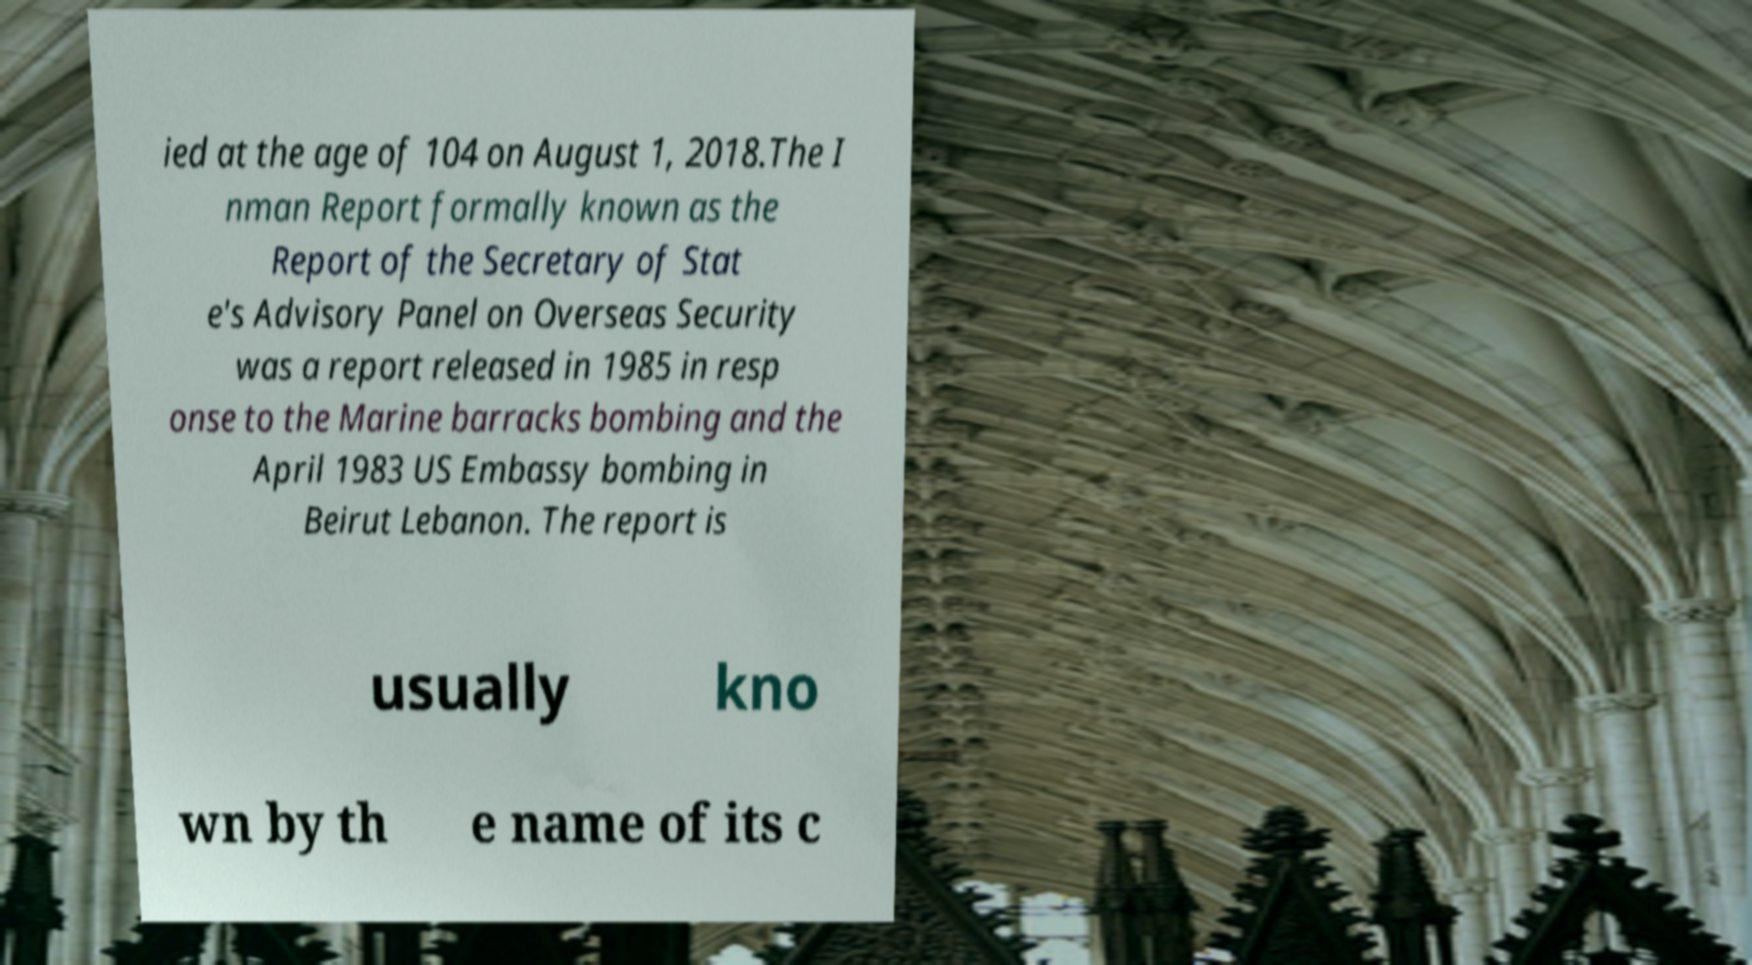I need the written content from this picture converted into text. Can you do that? ied at the age of 104 on August 1, 2018.The I nman Report formally known as the Report of the Secretary of Stat e's Advisory Panel on Overseas Security was a report released in 1985 in resp onse to the Marine barracks bombing and the April 1983 US Embassy bombing in Beirut Lebanon. The report is usually kno wn by th e name of its c 